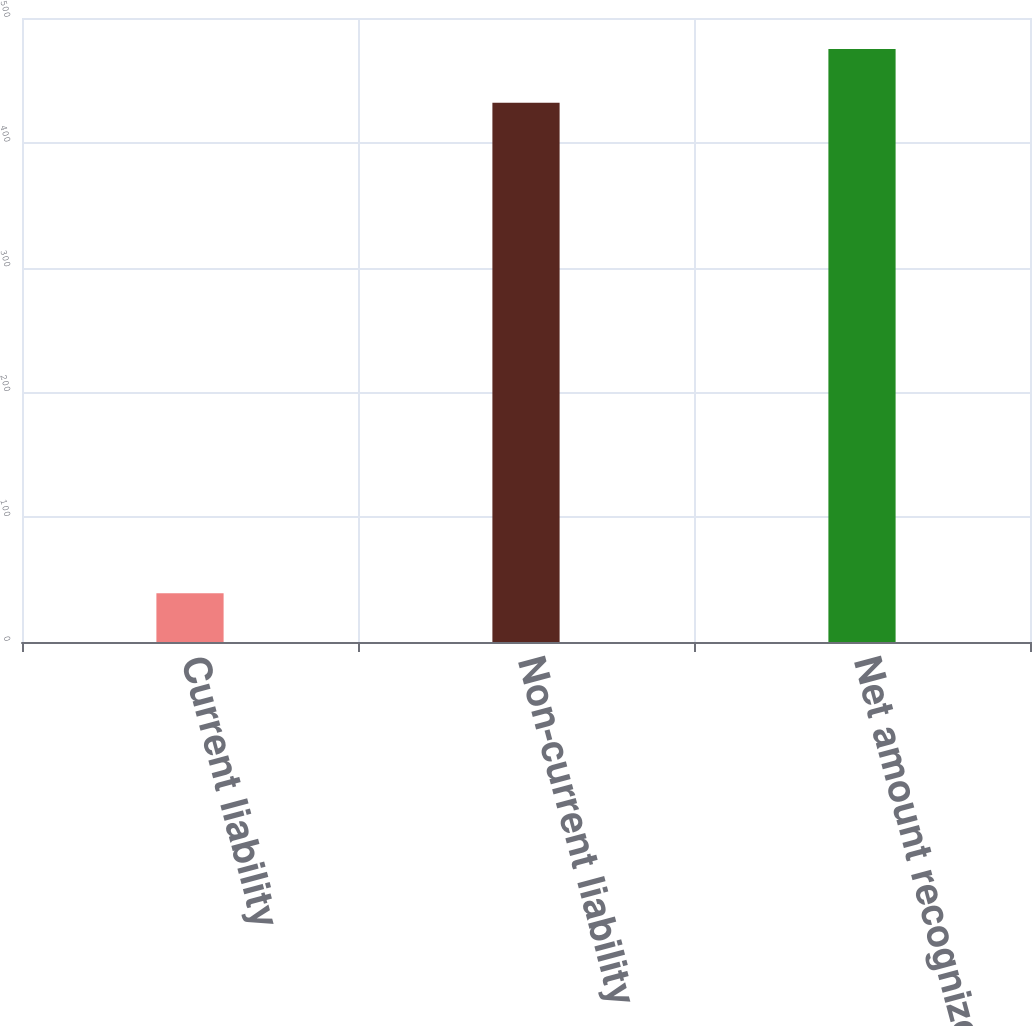Convert chart to OTSL. <chart><loc_0><loc_0><loc_500><loc_500><bar_chart><fcel>Current liability<fcel>Non-current liability<fcel>Net amount recognized<nl><fcel>39<fcel>432<fcel>475.2<nl></chart> 